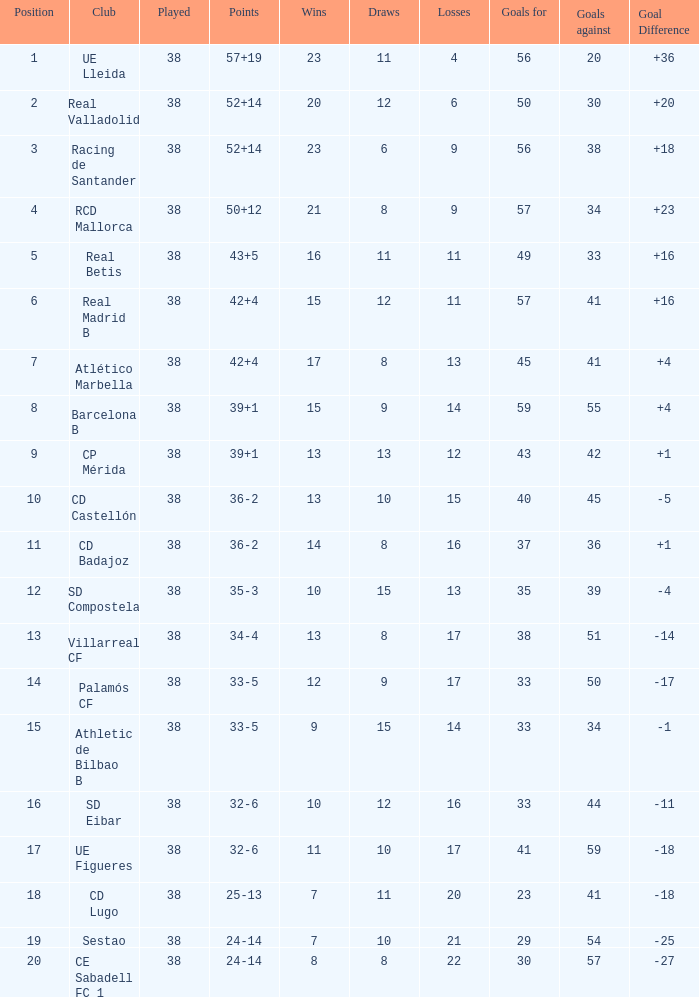Calculate the average goal difference given 51 goals allowed and less than 17 defeats. None. 